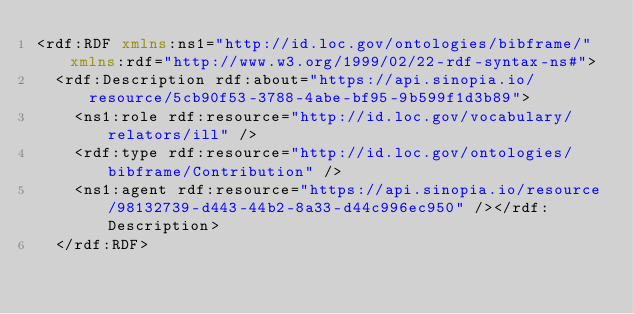Convert code to text. <code><loc_0><loc_0><loc_500><loc_500><_XML_><rdf:RDF xmlns:ns1="http://id.loc.gov/ontologies/bibframe/" xmlns:rdf="http://www.w3.org/1999/02/22-rdf-syntax-ns#">
  <rdf:Description rdf:about="https://api.sinopia.io/resource/5cb90f53-3788-4abe-bf95-9b599f1d3b89">
    <ns1:role rdf:resource="http://id.loc.gov/vocabulary/relators/ill" />
    <rdf:type rdf:resource="http://id.loc.gov/ontologies/bibframe/Contribution" />
    <ns1:agent rdf:resource="https://api.sinopia.io/resource/98132739-d443-44b2-8a33-d44c996ec950" /></rdf:Description>
  </rdf:RDF></code> 